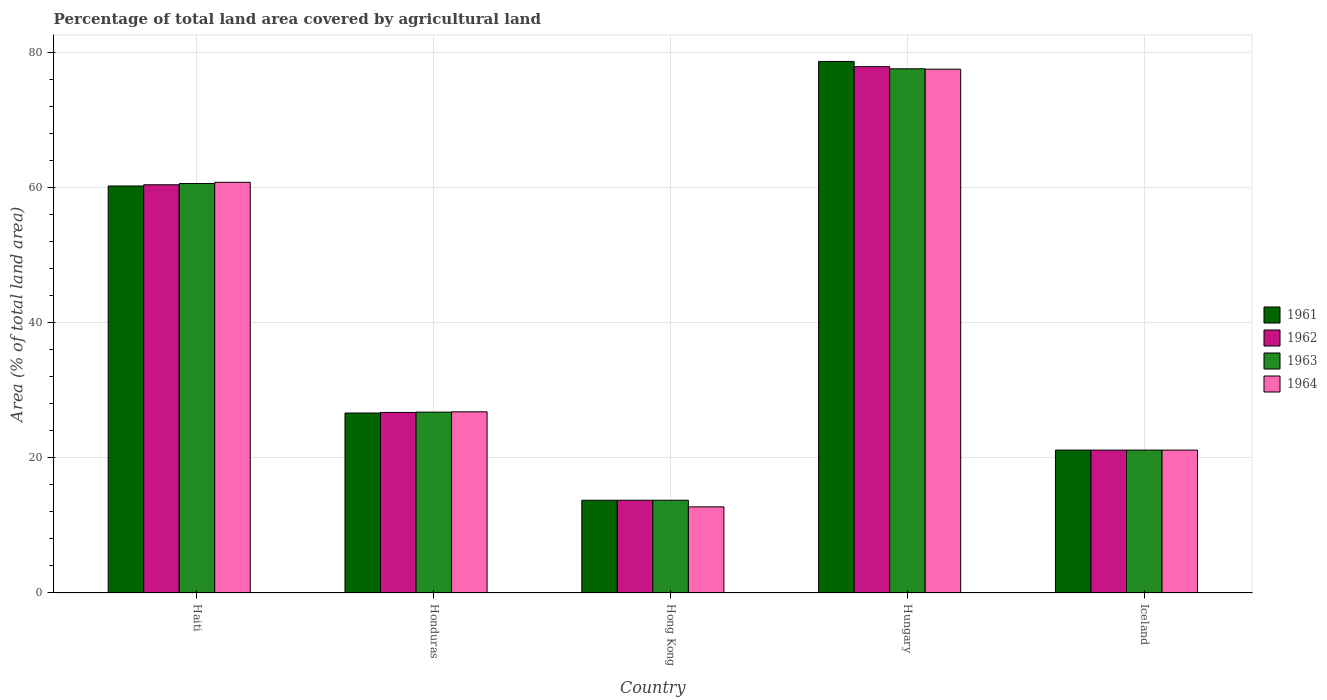Are the number of bars on each tick of the X-axis equal?
Provide a succinct answer. Yes. What is the label of the 5th group of bars from the left?
Give a very brief answer. Iceland. In how many cases, is the number of bars for a given country not equal to the number of legend labels?
Your answer should be compact. 0. What is the percentage of agricultural land in 1963 in Iceland?
Make the answer very short. 21.15. Across all countries, what is the maximum percentage of agricultural land in 1964?
Your answer should be compact. 77.52. Across all countries, what is the minimum percentage of agricultural land in 1962?
Your response must be concise. 13.73. In which country was the percentage of agricultural land in 1963 maximum?
Provide a succinct answer. Hungary. In which country was the percentage of agricultural land in 1962 minimum?
Provide a succinct answer. Hong Kong. What is the total percentage of agricultural land in 1962 in the graph?
Give a very brief answer. 199.9. What is the difference between the percentage of agricultural land in 1961 in Honduras and that in Hong Kong?
Your answer should be compact. 12.91. What is the difference between the percentage of agricultural land in 1964 in Hungary and the percentage of agricultural land in 1963 in Hong Kong?
Offer a very short reply. 63.79. What is the average percentage of agricultural land in 1962 per country?
Provide a short and direct response. 39.98. What is the ratio of the percentage of agricultural land in 1963 in Hong Kong to that in Hungary?
Make the answer very short. 0.18. Is the percentage of agricultural land in 1963 in Honduras less than that in Hong Kong?
Give a very brief answer. No. What is the difference between the highest and the second highest percentage of agricultural land in 1964?
Your response must be concise. -33.96. What is the difference between the highest and the lowest percentage of agricultural land in 1961?
Provide a succinct answer. 64.94. Is it the case that in every country, the sum of the percentage of agricultural land in 1964 and percentage of agricultural land in 1962 is greater than the sum of percentage of agricultural land in 1961 and percentage of agricultural land in 1963?
Your response must be concise. No. What does the 4th bar from the right in Iceland represents?
Make the answer very short. 1961. Is it the case that in every country, the sum of the percentage of agricultural land in 1963 and percentage of agricultural land in 1962 is greater than the percentage of agricultural land in 1961?
Your answer should be very brief. Yes. How many bars are there?
Ensure brevity in your answer.  20. How many countries are there in the graph?
Provide a short and direct response. 5. What is the difference between two consecutive major ticks on the Y-axis?
Your answer should be very brief. 20. Are the values on the major ticks of Y-axis written in scientific E-notation?
Offer a terse response. No. Does the graph contain any zero values?
Give a very brief answer. No. How are the legend labels stacked?
Offer a very short reply. Vertical. What is the title of the graph?
Make the answer very short. Percentage of total land area covered by agricultural land. Does "1991" appear as one of the legend labels in the graph?
Ensure brevity in your answer.  No. What is the label or title of the X-axis?
Provide a succinct answer. Country. What is the label or title of the Y-axis?
Ensure brevity in your answer.  Area (% of total land area). What is the Area (% of total land area) in 1961 in Haiti?
Your answer should be compact. 60.23. What is the Area (% of total land area) in 1962 in Haiti?
Offer a very short reply. 60.41. What is the Area (% of total land area) in 1963 in Haiti?
Provide a short and direct response. 60.6. What is the Area (% of total land area) of 1964 in Haiti?
Ensure brevity in your answer.  60.78. What is the Area (% of total land area) in 1961 in Honduras?
Ensure brevity in your answer.  26.63. What is the Area (% of total land area) of 1962 in Honduras?
Your answer should be very brief. 26.72. What is the Area (% of total land area) in 1963 in Honduras?
Keep it short and to the point. 26.77. What is the Area (% of total land area) in 1964 in Honduras?
Your answer should be compact. 26.81. What is the Area (% of total land area) in 1961 in Hong Kong?
Provide a succinct answer. 13.73. What is the Area (% of total land area) of 1962 in Hong Kong?
Ensure brevity in your answer.  13.73. What is the Area (% of total land area) of 1963 in Hong Kong?
Provide a succinct answer. 13.73. What is the Area (% of total land area) in 1964 in Hong Kong?
Provide a short and direct response. 12.75. What is the Area (% of total land area) of 1961 in Hungary?
Make the answer very short. 78.67. What is the Area (% of total land area) of 1962 in Hungary?
Offer a terse response. 77.89. What is the Area (% of total land area) in 1963 in Hungary?
Ensure brevity in your answer.  77.57. What is the Area (% of total land area) in 1964 in Hungary?
Your response must be concise. 77.52. What is the Area (% of total land area) of 1961 in Iceland?
Offer a terse response. 21.15. What is the Area (% of total land area) in 1962 in Iceland?
Ensure brevity in your answer.  21.15. What is the Area (% of total land area) of 1963 in Iceland?
Offer a very short reply. 21.15. What is the Area (% of total land area) of 1964 in Iceland?
Provide a short and direct response. 21.15. Across all countries, what is the maximum Area (% of total land area) in 1961?
Provide a short and direct response. 78.67. Across all countries, what is the maximum Area (% of total land area) of 1962?
Ensure brevity in your answer.  77.89. Across all countries, what is the maximum Area (% of total land area) of 1963?
Give a very brief answer. 77.57. Across all countries, what is the maximum Area (% of total land area) in 1964?
Provide a short and direct response. 77.52. Across all countries, what is the minimum Area (% of total land area) in 1961?
Offer a very short reply. 13.73. Across all countries, what is the minimum Area (% of total land area) of 1962?
Your answer should be very brief. 13.73. Across all countries, what is the minimum Area (% of total land area) of 1963?
Keep it short and to the point. 13.73. Across all countries, what is the minimum Area (% of total land area) of 1964?
Ensure brevity in your answer.  12.75. What is the total Area (% of total land area) in 1961 in the graph?
Make the answer very short. 200.4. What is the total Area (% of total land area) of 1962 in the graph?
Give a very brief answer. 199.9. What is the total Area (% of total land area) of 1963 in the graph?
Your answer should be very brief. 199.81. What is the total Area (% of total land area) in 1964 in the graph?
Keep it short and to the point. 199. What is the difference between the Area (% of total land area) of 1961 in Haiti and that in Honduras?
Offer a very short reply. 33.6. What is the difference between the Area (% of total land area) in 1962 in Haiti and that in Honduras?
Keep it short and to the point. 33.69. What is the difference between the Area (% of total land area) of 1963 in Haiti and that in Honduras?
Your response must be concise. 33.83. What is the difference between the Area (% of total land area) in 1964 in Haiti and that in Honduras?
Ensure brevity in your answer.  33.96. What is the difference between the Area (% of total land area) of 1961 in Haiti and that in Hong Kong?
Your answer should be very brief. 46.51. What is the difference between the Area (% of total land area) in 1962 in Haiti and that in Hong Kong?
Your answer should be compact. 46.69. What is the difference between the Area (% of total land area) in 1963 in Haiti and that in Hong Kong?
Provide a short and direct response. 46.87. What is the difference between the Area (% of total land area) in 1964 in Haiti and that in Hong Kong?
Make the answer very short. 48.03. What is the difference between the Area (% of total land area) of 1961 in Haiti and that in Hungary?
Offer a very short reply. -18.43. What is the difference between the Area (% of total land area) in 1962 in Haiti and that in Hungary?
Your answer should be very brief. -17.48. What is the difference between the Area (% of total land area) in 1963 in Haiti and that in Hungary?
Offer a very short reply. -16.98. What is the difference between the Area (% of total land area) in 1964 in Haiti and that in Hungary?
Your answer should be compact. -16.74. What is the difference between the Area (% of total land area) of 1961 in Haiti and that in Iceland?
Provide a succinct answer. 39.09. What is the difference between the Area (% of total land area) in 1962 in Haiti and that in Iceland?
Provide a succinct answer. 39.27. What is the difference between the Area (% of total land area) in 1963 in Haiti and that in Iceland?
Offer a terse response. 39.45. What is the difference between the Area (% of total land area) in 1964 in Haiti and that in Iceland?
Provide a short and direct response. 39.63. What is the difference between the Area (% of total land area) of 1961 in Honduras and that in Hong Kong?
Give a very brief answer. 12.91. What is the difference between the Area (% of total land area) of 1962 in Honduras and that in Hong Kong?
Keep it short and to the point. 13. What is the difference between the Area (% of total land area) in 1963 in Honduras and that in Hong Kong?
Give a very brief answer. 13.04. What is the difference between the Area (% of total land area) in 1964 in Honduras and that in Hong Kong?
Keep it short and to the point. 14.07. What is the difference between the Area (% of total land area) of 1961 in Honduras and that in Hungary?
Offer a terse response. -52.03. What is the difference between the Area (% of total land area) of 1962 in Honduras and that in Hungary?
Your answer should be compact. -51.17. What is the difference between the Area (% of total land area) in 1963 in Honduras and that in Hungary?
Offer a very short reply. -50.81. What is the difference between the Area (% of total land area) of 1964 in Honduras and that in Hungary?
Keep it short and to the point. -50.71. What is the difference between the Area (% of total land area) of 1961 in Honduras and that in Iceland?
Offer a very short reply. 5.49. What is the difference between the Area (% of total land area) of 1962 in Honduras and that in Iceland?
Provide a short and direct response. 5.58. What is the difference between the Area (% of total land area) in 1963 in Honduras and that in Iceland?
Your response must be concise. 5.62. What is the difference between the Area (% of total land area) in 1964 in Honduras and that in Iceland?
Provide a short and direct response. 5.66. What is the difference between the Area (% of total land area) of 1961 in Hong Kong and that in Hungary?
Offer a very short reply. -64.94. What is the difference between the Area (% of total land area) in 1962 in Hong Kong and that in Hungary?
Keep it short and to the point. -64.17. What is the difference between the Area (% of total land area) of 1963 in Hong Kong and that in Hungary?
Provide a short and direct response. -63.85. What is the difference between the Area (% of total land area) of 1964 in Hong Kong and that in Hungary?
Provide a succinct answer. -64.77. What is the difference between the Area (% of total land area) in 1961 in Hong Kong and that in Iceland?
Your answer should be very brief. -7.42. What is the difference between the Area (% of total land area) in 1962 in Hong Kong and that in Iceland?
Give a very brief answer. -7.42. What is the difference between the Area (% of total land area) of 1963 in Hong Kong and that in Iceland?
Keep it short and to the point. -7.42. What is the difference between the Area (% of total land area) in 1964 in Hong Kong and that in Iceland?
Your answer should be very brief. -8.4. What is the difference between the Area (% of total land area) of 1961 in Hungary and that in Iceland?
Give a very brief answer. 57.52. What is the difference between the Area (% of total land area) in 1962 in Hungary and that in Iceland?
Your answer should be very brief. 56.75. What is the difference between the Area (% of total land area) in 1963 in Hungary and that in Iceland?
Offer a very short reply. 56.43. What is the difference between the Area (% of total land area) in 1964 in Hungary and that in Iceland?
Your response must be concise. 56.37. What is the difference between the Area (% of total land area) of 1961 in Haiti and the Area (% of total land area) of 1962 in Honduras?
Your response must be concise. 33.51. What is the difference between the Area (% of total land area) of 1961 in Haiti and the Area (% of total land area) of 1963 in Honduras?
Provide a short and direct response. 33.46. What is the difference between the Area (% of total land area) in 1961 in Haiti and the Area (% of total land area) in 1964 in Honduras?
Your answer should be compact. 33.42. What is the difference between the Area (% of total land area) in 1962 in Haiti and the Area (% of total land area) in 1963 in Honduras?
Make the answer very short. 33.65. What is the difference between the Area (% of total land area) of 1962 in Haiti and the Area (% of total land area) of 1964 in Honduras?
Offer a terse response. 33.6. What is the difference between the Area (% of total land area) of 1963 in Haiti and the Area (% of total land area) of 1964 in Honduras?
Keep it short and to the point. 33.78. What is the difference between the Area (% of total land area) of 1961 in Haiti and the Area (% of total land area) of 1962 in Hong Kong?
Offer a terse response. 46.51. What is the difference between the Area (% of total land area) of 1961 in Haiti and the Area (% of total land area) of 1963 in Hong Kong?
Offer a terse response. 46.51. What is the difference between the Area (% of total land area) of 1961 in Haiti and the Area (% of total land area) of 1964 in Hong Kong?
Offer a terse response. 47.49. What is the difference between the Area (% of total land area) in 1962 in Haiti and the Area (% of total land area) in 1963 in Hong Kong?
Your answer should be very brief. 46.69. What is the difference between the Area (% of total land area) in 1962 in Haiti and the Area (% of total land area) in 1964 in Hong Kong?
Give a very brief answer. 47.67. What is the difference between the Area (% of total land area) of 1963 in Haiti and the Area (% of total land area) of 1964 in Hong Kong?
Offer a terse response. 47.85. What is the difference between the Area (% of total land area) in 1961 in Haiti and the Area (% of total land area) in 1962 in Hungary?
Make the answer very short. -17.66. What is the difference between the Area (% of total land area) in 1961 in Haiti and the Area (% of total land area) in 1963 in Hungary?
Ensure brevity in your answer.  -17.34. What is the difference between the Area (% of total land area) of 1961 in Haiti and the Area (% of total land area) of 1964 in Hungary?
Provide a succinct answer. -17.29. What is the difference between the Area (% of total land area) in 1962 in Haiti and the Area (% of total land area) in 1963 in Hungary?
Provide a short and direct response. -17.16. What is the difference between the Area (% of total land area) in 1962 in Haiti and the Area (% of total land area) in 1964 in Hungary?
Your answer should be compact. -17.11. What is the difference between the Area (% of total land area) of 1963 in Haiti and the Area (% of total land area) of 1964 in Hungary?
Provide a succinct answer. -16.92. What is the difference between the Area (% of total land area) in 1961 in Haiti and the Area (% of total land area) in 1962 in Iceland?
Provide a short and direct response. 39.09. What is the difference between the Area (% of total land area) of 1961 in Haiti and the Area (% of total land area) of 1963 in Iceland?
Offer a very short reply. 39.09. What is the difference between the Area (% of total land area) of 1961 in Haiti and the Area (% of total land area) of 1964 in Iceland?
Ensure brevity in your answer.  39.09. What is the difference between the Area (% of total land area) in 1962 in Haiti and the Area (% of total land area) in 1963 in Iceland?
Provide a short and direct response. 39.27. What is the difference between the Area (% of total land area) of 1962 in Haiti and the Area (% of total land area) of 1964 in Iceland?
Your answer should be compact. 39.27. What is the difference between the Area (% of total land area) in 1963 in Haiti and the Area (% of total land area) in 1964 in Iceland?
Make the answer very short. 39.45. What is the difference between the Area (% of total land area) in 1961 in Honduras and the Area (% of total land area) in 1962 in Hong Kong?
Provide a short and direct response. 12.91. What is the difference between the Area (% of total land area) of 1961 in Honduras and the Area (% of total land area) of 1963 in Hong Kong?
Your response must be concise. 12.91. What is the difference between the Area (% of total land area) in 1961 in Honduras and the Area (% of total land area) in 1964 in Hong Kong?
Provide a short and direct response. 13.89. What is the difference between the Area (% of total land area) in 1962 in Honduras and the Area (% of total land area) in 1963 in Hong Kong?
Offer a terse response. 13. What is the difference between the Area (% of total land area) of 1962 in Honduras and the Area (% of total land area) of 1964 in Hong Kong?
Your answer should be compact. 13.98. What is the difference between the Area (% of total land area) in 1963 in Honduras and the Area (% of total land area) in 1964 in Hong Kong?
Keep it short and to the point. 14.02. What is the difference between the Area (% of total land area) in 1961 in Honduras and the Area (% of total land area) in 1962 in Hungary?
Ensure brevity in your answer.  -51.26. What is the difference between the Area (% of total land area) in 1961 in Honduras and the Area (% of total land area) in 1963 in Hungary?
Keep it short and to the point. -50.94. What is the difference between the Area (% of total land area) of 1961 in Honduras and the Area (% of total land area) of 1964 in Hungary?
Your answer should be very brief. -50.89. What is the difference between the Area (% of total land area) of 1962 in Honduras and the Area (% of total land area) of 1963 in Hungary?
Provide a short and direct response. -50.85. What is the difference between the Area (% of total land area) in 1962 in Honduras and the Area (% of total land area) in 1964 in Hungary?
Give a very brief answer. -50.8. What is the difference between the Area (% of total land area) of 1963 in Honduras and the Area (% of total land area) of 1964 in Hungary?
Offer a terse response. -50.75. What is the difference between the Area (% of total land area) in 1961 in Honduras and the Area (% of total land area) in 1962 in Iceland?
Offer a very short reply. 5.49. What is the difference between the Area (% of total land area) in 1961 in Honduras and the Area (% of total land area) in 1963 in Iceland?
Keep it short and to the point. 5.49. What is the difference between the Area (% of total land area) of 1961 in Honduras and the Area (% of total land area) of 1964 in Iceland?
Make the answer very short. 5.49. What is the difference between the Area (% of total land area) of 1962 in Honduras and the Area (% of total land area) of 1963 in Iceland?
Your response must be concise. 5.58. What is the difference between the Area (% of total land area) in 1962 in Honduras and the Area (% of total land area) in 1964 in Iceland?
Your answer should be very brief. 5.58. What is the difference between the Area (% of total land area) of 1963 in Honduras and the Area (% of total land area) of 1964 in Iceland?
Your response must be concise. 5.62. What is the difference between the Area (% of total land area) in 1961 in Hong Kong and the Area (% of total land area) in 1962 in Hungary?
Offer a terse response. -64.17. What is the difference between the Area (% of total land area) of 1961 in Hong Kong and the Area (% of total land area) of 1963 in Hungary?
Your answer should be very brief. -63.85. What is the difference between the Area (% of total land area) in 1961 in Hong Kong and the Area (% of total land area) in 1964 in Hungary?
Provide a short and direct response. -63.79. What is the difference between the Area (% of total land area) in 1962 in Hong Kong and the Area (% of total land area) in 1963 in Hungary?
Give a very brief answer. -63.85. What is the difference between the Area (% of total land area) in 1962 in Hong Kong and the Area (% of total land area) in 1964 in Hungary?
Provide a short and direct response. -63.79. What is the difference between the Area (% of total land area) of 1963 in Hong Kong and the Area (% of total land area) of 1964 in Hungary?
Offer a very short reply. -63.79. What is the difference between the Area (% of total land area) in 1961 in Hong Kong and the Area (% of total land area) in 1962 in Iceland?
Your answer should be compact. -7.42. What is the difference between the Area (% of total land area) of 1961 in Hong Kong and the Area (% of total land area) of 1963 in Iceland?
Provide a short and direct response. -7.42. What is the difference between the Area (% of total land area) in 1961 in Hong Kong and the Area (% of total land area) in 1964 in Iceland?
Offer a very short reply. -7.42. What is the difference between the Area (% of total land area) in 1962 in Hong Kong and the Area (% of total land area) in 1963 in Iceland?
Offer a very short reply. -7.42. What is the difference between the Area (% of total land area) in 1962 in Hong Kong and the Area (% of total land area) in 1964 in Iceland?
Provide a succinct answer. -7.42. What is the difference between the Area (% of total land area) of 1963 in Hong Kong and the Area (% of total land area) of 1964 in Iceland?
Your answer should be very brief. -7.42. What is the difference between the Area (% of total land area) of 1961 in Hungary and the Area (% of total land area) of 1962 in Iceland?
Make the answer very short. 57.52. What is the difference between the Area (% of total land area) of 1961 in Hungary and the Area (% of total land area) of 1963 in Iceland?
Make the answer very short. 57.52. What is the difference between the Area (% of total land area) in 1961 in Hungary and the Area (% of total land area) in 1964 in Iceland?
Your response must be concise. 57.52. What is the difference between the Area (% of total land area) in 1962 in Hungary and the Area (% of total land area) in 1963 in Iceland?
Your answer should be very brief. 56.75. What is the difference between the Area (% of total land area) of 1962 in Hungary and the Area (% of total land area) of 1964 in Iceland?
Your answer should be compact. 56.75. What is the difference between the Area (% of total land area) of 1963 in Hungary and the Area (% of total land area) of 1964 in Iceland?
Your response must be concise. 56.43. What is the average Area (% of total land area) of 1961 per country?
Offer a very short reply. 40.08. What is the average Area (% of total land area) in 1962 per country?
Ensure brevity in your answer.  39.98. What is the average Area (% of total land area) of 1963 per country?
Provide a short and direct response. 39.96. What is the average Area (% of total land area) in 1964 per country?
Provide a succinct answer. 39.8. What is the difference between the Area (% of total land area) in 1961 and Area (% of total land area) in 1962 in Haiti?
Ensure brevity in your answer.  -0.18. What is the difference between the Area (% of total land area) in 1961 and Area (% of total land area) in 1963 in Haiti?
Offer a terse response. -0.36. What is the difference between the Area (% of total land area) in 1961 and Area (% of total land area) in 1964 in Haiti?
Your answer should be very brief. -0.54. What is the difference between the Area (% of total land area) in 1962 and Area (% of total land area) in 1963 in Haiti?
Offer a very short reply. -0.18. What is the difference between the Area (% of total land area) of 1962 and Area (% of total land area) of 1964 in Haiti?
Make the answer very short. -0.36. What is the difference between the Area (% of total land area) of 1963 and Area (% of total land area) of 1964 in Haiti?
Your answer should be very brief. -0.18. What is the difference between the Area (% of total land area) of 1961 and Area (% of total land area) of 1962 in Honduras?
Your answer should be very brief. -0.09. What is the difference between the Area (% of total land area) in 1961 and Area (% of total land area) in 1963 in Honduras?
Ensure brevity in your answer.  -0.13. What is the difference between the Area (% of total land area) in 1961 and Area (% of total land area) in 1964 in Honduras?
Your answer should be very brief. -0.18. What is the difference between the Area (% of total land area) in 1962 and Area (% of total land area) in 1963 in Honduras?
Make the answer very short. -0.04. What is the difference between the Area (% of total land area) of 1962 and Area (% of total land area) of 1964 in Honduras?
Provide a short and direct response. -0.09. What is the difference between the Area (% of total land area) of 1963 and Area (% of total land area) of 1964 in Honduras?
Provide a succinct answer. -0.04. What is the difference between the Area (% of total land area) of 1961 and Area (% of total land area) of 1962 in Hong Kong?
Your response must be concise. 0. What is the difference between the Area (% of total land area) of 1961 and Area (% of total land area) of 1964 in Hong Kong?
Provide a short and direct response. 0.98. What is the difference between the Area (% of total land area) of 1962 and Area (% of total land area) of 1964 in Hong Kong?
Your response must be concise. 0.98. What is the difference between the Area (% of total land area) of 1963 and Area (% of total land area) of 1964 in Hong Kong?
Ensure brevity in your answer.  0.98. What is the difference between the Area (% of total land area) in 1961 and Area (% of total land area) in 1962 in Hungary?
Keep it short and to the point. 0.77. What is the difference between the Area (% of total land area) in 1961 and Area (% of total land area) in 1964 in Hungary?
Ensure brevity in your answer.  1.15. What is the difference between the Area (% of total land area) of 1962 and Area (% of total land area) of 1963 in Hungary?
Your answer should be very brief. 0.32. What is the difference between the Area (% of total land area) of 1962 and Area (% of total land area) of 1964 in Hungary?
Give a very brief answer. 0.38. What is the difference between the Area (% of total land area) of 1963 and Area (% of total land area) of 1964 in Hungary?
Offer a terse response. 0.06. What is the difference between the Area (% of total land area) of 1962 and Area (% of total land area) of 1964 in Iceland?
Give a very brief answer. 0. What is the difference between the Area (% of total land area) of 1963 and Area (% of total land area) of 1964 in Iceland?
Your response must be concise. 0. What is the ratio of the Area (% of total land area) in 1961 in Haiti to that in Honduras?
Your answer should be very brief. 2.26. What is the ratio of the Area (% of total land area) of 1962 in Haiti to that in Honduras?
Offer a very short reply. 2.26. What is the ratio of the Area (% of total land area) in 1963 in Haiti to that in Honduras?
Make the answer very short. 2.26. What is the ratio of the Area (% of total land area) in 1964 in Haiti to that in Honduras?
Make the answer very short. 2.27. What is the ratio of the Area (% of total land area) in 1961 in Haiti to that in Hong Kong?
Your answer should be compact. 4.39. What is the ratio of the Area (% of total land area) in 1962 in Haiti to that in Hong Kong?
Provide a short and direct response. 4.4. What is the ratio of the Area (% of total land area) in 1963 in Haiti to that in Hong Kong?
Offer a terse response. 4.41. What is the ratio of the Area (% of total land area) in 1964 in Haiti to that in Hong Kong?
Offer a terse response. 4.77. What is the ratio of the Area (% of total land area) in 1961 in Haiti to that in Hungary?
Offer a terse response. 0.77. What is the ratio of the Area (% of total land area) of 1962 in Haiti to that in Hungary?
Give a very brief answer. 0.78. What is the ratio of the Area (% of total land area) of 1963 in Haiti to that in Hungary?
Give a very brief answer. 0.78. What is the ratio of the Area (% of total land area) of 1964 in Haiti to that in Hungary?
Offer a very short reply. 0.78. What is the ratio of the Area (% of total land area) in 1961 in Haiti to that in Iceland?
Provide a short and direct response. 2.85. What is the ratio of the Area (% of total land area) of 1962 in Haiti to that in Iceland?
Your answer should be compact. 2.86. What is the ratio of the Area (% of total land area) of 1963 in Haiti to that in Iceland?
Offer a very short reply. 2.87. What is the ratio of the Area (% of total land area) of 1964 in Haiti to that in Iceland?
Your answer should be very brief. 2.87. What is the ratio of the Area (% of total land area) of 1961 in Honduras to that in Hong Kong?
Give a very brief answer. 1.94. What is the ratio of the Area (% of total land area) in 1962 in Honduras to that in Hong Kong?
Your response must be concise. 1.95. What is the ratio of the Area (% of total land area) of 1963 in Honduras to that in Hong Kong?
Provide a short and direct response. 1.95. What is the ratio of the Area (% of total land area) of 1964 in Honduras to that in Hong Kong?
Your answer should be compact. 2.1. What is the ratio of the Area (% of total land area) of 1961 in Honduras to that in Hungary?
Provide a short and direct response. 0.34. What is the ratio of the Area (% of total land area) of 1962 in Honduras to that in Hungary?
Ensure brevity in your answer.  0.34. What is the ratio of the Area (% of total land area) in 1963 in Honduras to that in Hungary?
Your answer should be very brief. 0.35. What is the ratio of the Area (% of total land area) of 1964 in Honduras to that in Hungary?
Offer a very short reply. 0.35. What is the ratio of the Area (% of total land area) in 1961 in Honduras to that in Iceland?
Offer a very short reply. 1.26. What is the ratio of the Area (% of total land area) of 1962 in Honduras to that in Iceland?
Provide a succinct answer. 1.26. What is the ratio of the Area (% of total land area) in 1963 in Honduras to that in Iceland?
Your answer should be very brief. 1.27. What is the ratio of the Area (% of total land area) in 1964 in Honduras to that in Iceland?
Give a very brief answer. 1.27. What is the ratio of the Area (% of total land area) in 1961 in Hong Kong to that in Hungary?
Ensure brevity in your answer.  0.17. What is the ratio of the Area (% of total land area) in 1962 in Hong Kong to that in Hungary?
Your answer should be compact. 0.18. What is the ratio of the Area (% of total land area) in 1963 in Hong Kong to that in Hungary?
Your answer should be very brief. 0.18. What is the ratio of the Area (% of total land area) in 1964 in Hong Kong to that in Hungary?
Keep it short and to the point. 0.16. What is the ratio of the Area (% of total land area) of 1961 in Hong Kong to that in Iceland?
Offer a very short reply. 0.65. What is the ratio of the Area (% of total land area) in 1962 in Hong Kong to that in Iceland?
Make the answer very short. 0.65. What is the ratio of the Area (% of total land area) in 1963 in Hong Kong to that in Iceland?
Ensure brevity in your answer.  0.65. What is the ratio of the Area (% of total land area) in 1964 in Hong Kong to that in Iceland?
Ensure brevity in your answer.  0.6. What is the ratio of the Area (% of total land area) of 1961 in Hungary to that in Iceland?
Your response must be concise. 3.72. What is the ratio of the Area (% of total land area) in 1962 in Hungary to that in Iceland?
Make the answer very short. 3.68. What is the ratio of the Area (% of total land area) of 1963 in Hungary to that in Iceland?
Give a very brief answer. 3.67. What is the ratio of the Area (% of total land area) in 1964 in Hungary to that in Iceland?
Keep it short and to the point. 3.67. What is the difference between the highest and the second highest Area (% of total land area) of 1961?
Provide a succinct answer. 18.43. What is the difference between the highest and the second highest Area (% of total land area) in 1962?
Provide a short and direct response. 17.48. What is the difference between the highest and the second highest Area (% of total land area) of 1963?
Offer a very short reply. 16.98. What is the difference between the highest and the second highest Area (% of total land area) of 1964?
Keep it short and to the point. 16.74. What is the difference between the highest and the lowest Area (% of total land area) of 1961?
Your answer should be very brief. 64.94. What is the difference between the highest and the lowest Area (% of total land area) of 1962?
Provide a succinct answer. 64.17. What is the difference between the highest and the lowest Area (% of total land area) of 1963?
Offer a very short reply. 63.85. What is the difference between the highest and the lowest Area (% of total land area) of 1964?
Your answer should be very brief. 64.77. 